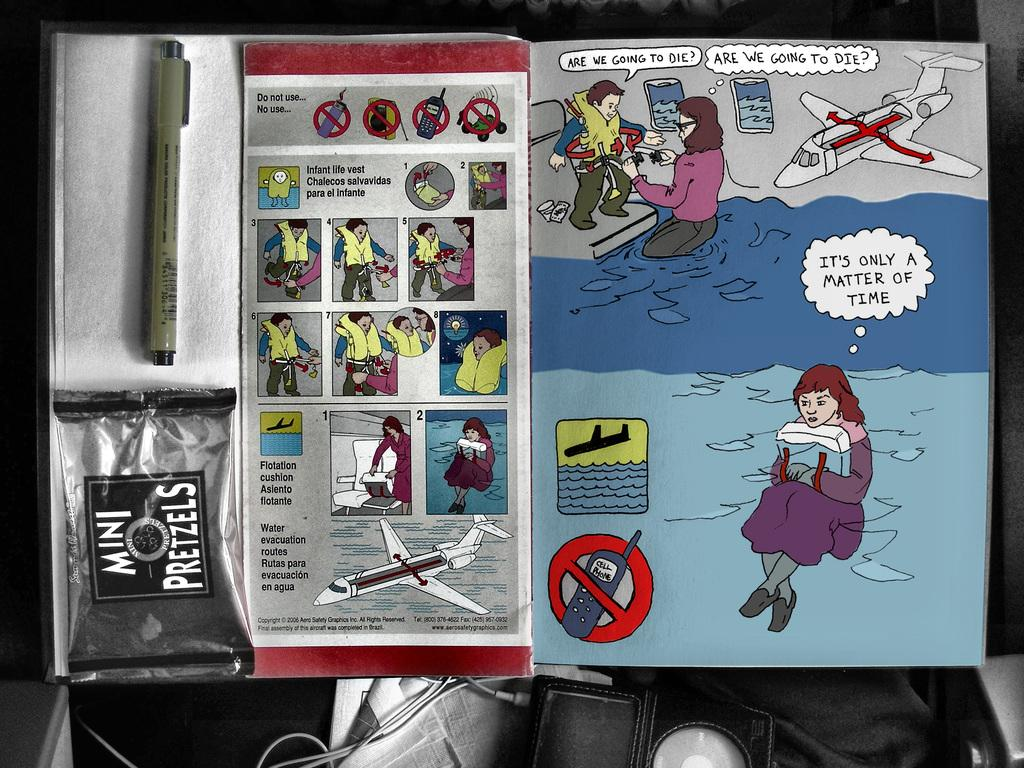What is on the paper in the image? There are texts and drawings on the paper in the image. What type of objects are depicted in the drawings? Planes are depicted in the drawings on the paper. What writing instrument is visible in the image? A pen is visible in the image. What type of toothpaste is being used to draw the planes on the paper? There is no toothpaste present in the image; the drawings are made with a pen. How are the bushes being pushed in the image? There are no bushes present in the image. 